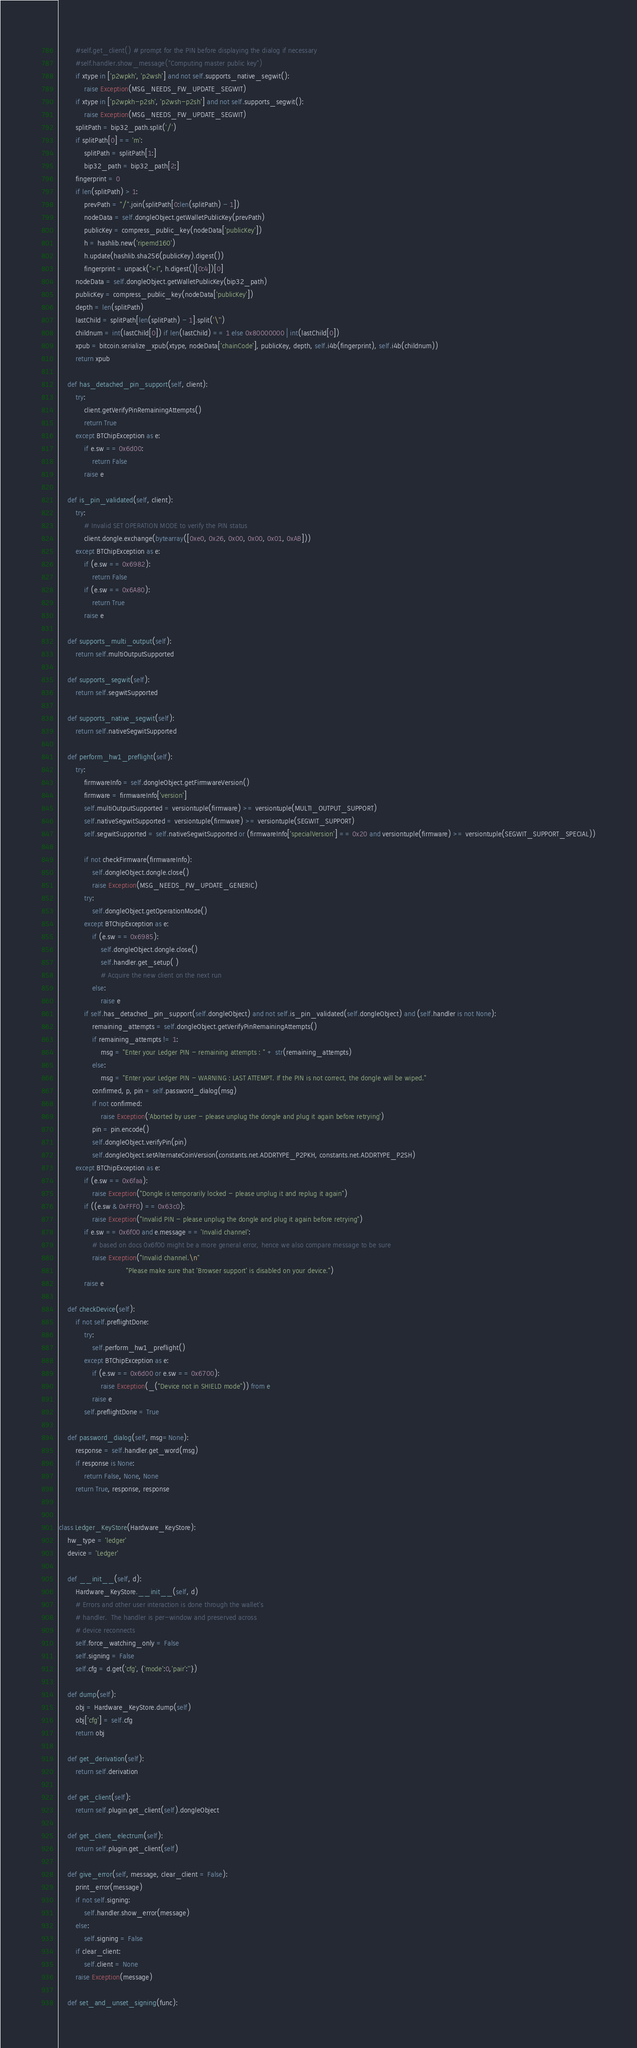<code> <loc_0><loc_0><loc_500><loc_500><_Python_>        #self.get_client() # prompt for the PIN before displaying the dialog if necessary
        #self.handler.show_message("Computing master public key")
        if xtype in ['p2wpkh', 'p2wsh'] and not self.supports_native_segwit():
            raise Exception(MSG_NEEDS_FW_UPDATE_SEGWIT)
        if xtype in ['p2wpkh-p2sh', 'p2wsh-p2sh'] and not self.supports_segwit():
            raise Exception(MSG_NEEDS_FW_UPDATE_SEGWIT)
        splitPath = bip32_path.split('/')
        if splitPath[0] == 'm':
            splitPath = splitPath[1:]
            bip32_path = bip32_path[2:]
        fingerprint = 0
        if len(splitPath) > 1:
            prevPath = "/".join(splitPath[0:len(splitPath) - 1])
            nodeData = self.dongleObject.getWalletPublicKey(prevPath)
            publicKey = compress_public_key(nodeData['publicKey'])
            h = hashlib.new('ripemd160')
            h.update(hashlib.sha256(publicKey).digest())
            fingerprint = unpack(">I", h.digest()[0:4])[0]
        nodeData = self.dongleObject.getWalletPublicKey(bip32_path)
        publicKey = compress_public_key(nodeData['publicKey'])
        depth = len(splitPath)
        lastChild = splitPath[len(splitPath) - 1].split('\'')
        childnum = int(lastChild[0]) if len(lastChild) == 1 else 0x80000000 | int(lastChild[0])
        xpub = bitcoin.serialize_xpub(xtype, nodeData['chainCode'], publicKey, depth, self.i4b(fingerprint), self.i4b(childnum))
        return xpub

    def has_detached_pin_support(self, client):
        try:
            client.getVerifyPinRemainingAttempts()
            return True
        except BTChipException as e:
            if e.sw == 0x6d00:
                return False
            raise e

    def is_pin_validated(self, client):
        try:
            # Invalid SET OPERATION MODE to verify the PIN status
            client.dongle.exchange(bytearray([0xe0, 0x26, 0x00, 0x00, 0x01, 0xAB]))
        except BTChipException as e:
            if (e.sw == 0x6982):
                return False
            if (e.sw == 0x6A80):
                return True
            raise e

    def supports_multi_output(self):
        return self.multiOutputSupported

    def supports_segwit(self):
        return self.segwitSupported

    def supports_native_segwit(self):
        return self.nativeSegwitSupported

    def perform_hw1_preflight(self):
        try:
            firmwareInfo = self.dongleObject.getFirmwareVersion()
            firmware = firmwareInfo['version']
            self.multiOutputSupported = versiontuple(firmware) >= versiontuple(MULTI_OUTPUT_SUPPORT)
            self.nativeSegwitSupported = versiontuple(firmware) >= versiontuple(SEGWIT_SUPPORT)
            self.segwitSupported = self.nativeSegwitSupported or (firmwareInfo['specialVersion'] == 0x20 and versiontuple(firmware) >= versiontuple(SEGWIT_SUPPORT_SPECIAL))

            if not checkFirmware(firmwareInfo):
                self.dongleObject.dongle.close()
                raise Exception(MSG_NEEDS_FW_UPDATE_GENERIC)
            try:
                self.dongleObject.getOperationMode()
            except BTChipException as e:
                if (e.sw == 0x6985):
                    self.dongleObject.dongle.close()
                    self.handler.get_setup( )
                    # Acquire the new client on the next run
                else:
                    raise e
            if self.has_detached_pin_support(self.dongleObject) and not self.is_pin_validated(self.dongleObject) and (self.handler is not None):
                remaining_attempts = self.dongleObject.getVerifyPinRemainingAttempts()
                if remaining_attempts != 1:
                    msg = "Enter your Ledger PIN - remaining attempts : " + str(remaining_attempts)
                else:
                    msg = "Enter your Ledger PIN - WARNING : LAST ATTEMPT. If the PIN is not correct, the dongle will be wiped."
                confirmed, p, pin = self.password_dialog(msg)
                if not confirmed:
                    raise Exception('Aborted by user - please unplug the dongle and plug it again before retrying')
                pin = pin.encode()
                self.dongleObject.verifyPin(pin)
                self.dongleObject.setAlternateCoinVersion(constants.net.ADDRTYPE_P2PKH, constants.net.ADDRTYPE_P2SH)
        except BTChipException as e:
            if (e.sw == 0x6faa):
                raise Exception("Dongle is temporarily locked - please unplug it and replug it again")
            if ((e.sw & 0xFFF0) == 0x63c0):
                raise Exception("Invalid PIN - please unplug the dongle and plug it again before retrying")
            if e.sw == 0x6f00 and e.message == 'Invalid channel':
                # based on docs 0x6f00 might be a more general error, hence we also compare message to be sure
                raise Exception("Invalid channel.\n"
                                "Please make sure that 'Browser support' is disabled on your device.")
            raise e

    def checkDevice(self):
        if not self.preflightDone:
            try:
                self.perform_hw1_preflight()
            except BTChipException as e:
                if (e.sw == 0x6d00 or e.sw == 0x6700):
                    raise Exception(_("Device not in SHIELD mode")) from e
                raise e
            self.preflightDone = True

    def password_dialog(self, msg=None):
        response = self.handler.get_word(msg)
        if response is None:
            return False, None, None
        return True, response, response


class Ledger_KeyStore(Hardware_KeyStore):
    hw_type = 'ledger'
    device = 'Ledger'

    def __init__(self, d):
        Hardware_KeyStore.__init__(self, d)
        # Errors and other user interaction is done through the wallet's
        # handler.  The handler is per-window and preserved across
        # device reconnects
        self.force_watching_only = False
        self.signing = False
        self.cfg = d.get('cfg', {'mode':0,'pair':''})

    def dump(self):
        obj = Hardware_KeyStore.dump(self)
        obj['cfg'] = self.cfg
        return obj

    def get_derivation(self):
        return self.derivation

    def get_client(self):
        return self.plugin.get_client(self).dongleObject

    def get_client_electrum(self):
        return self.plugin.get_client(self)

    def give_error(self, message, clear_client = False):
        print_error(message)
        if not self.signing:
            self.handler.show_error(message)
        else:
            self.signing = False
        if clear_client:
            self.client = None
        raise Exception(message)

    def set_and_unset_signing(func):</code> 